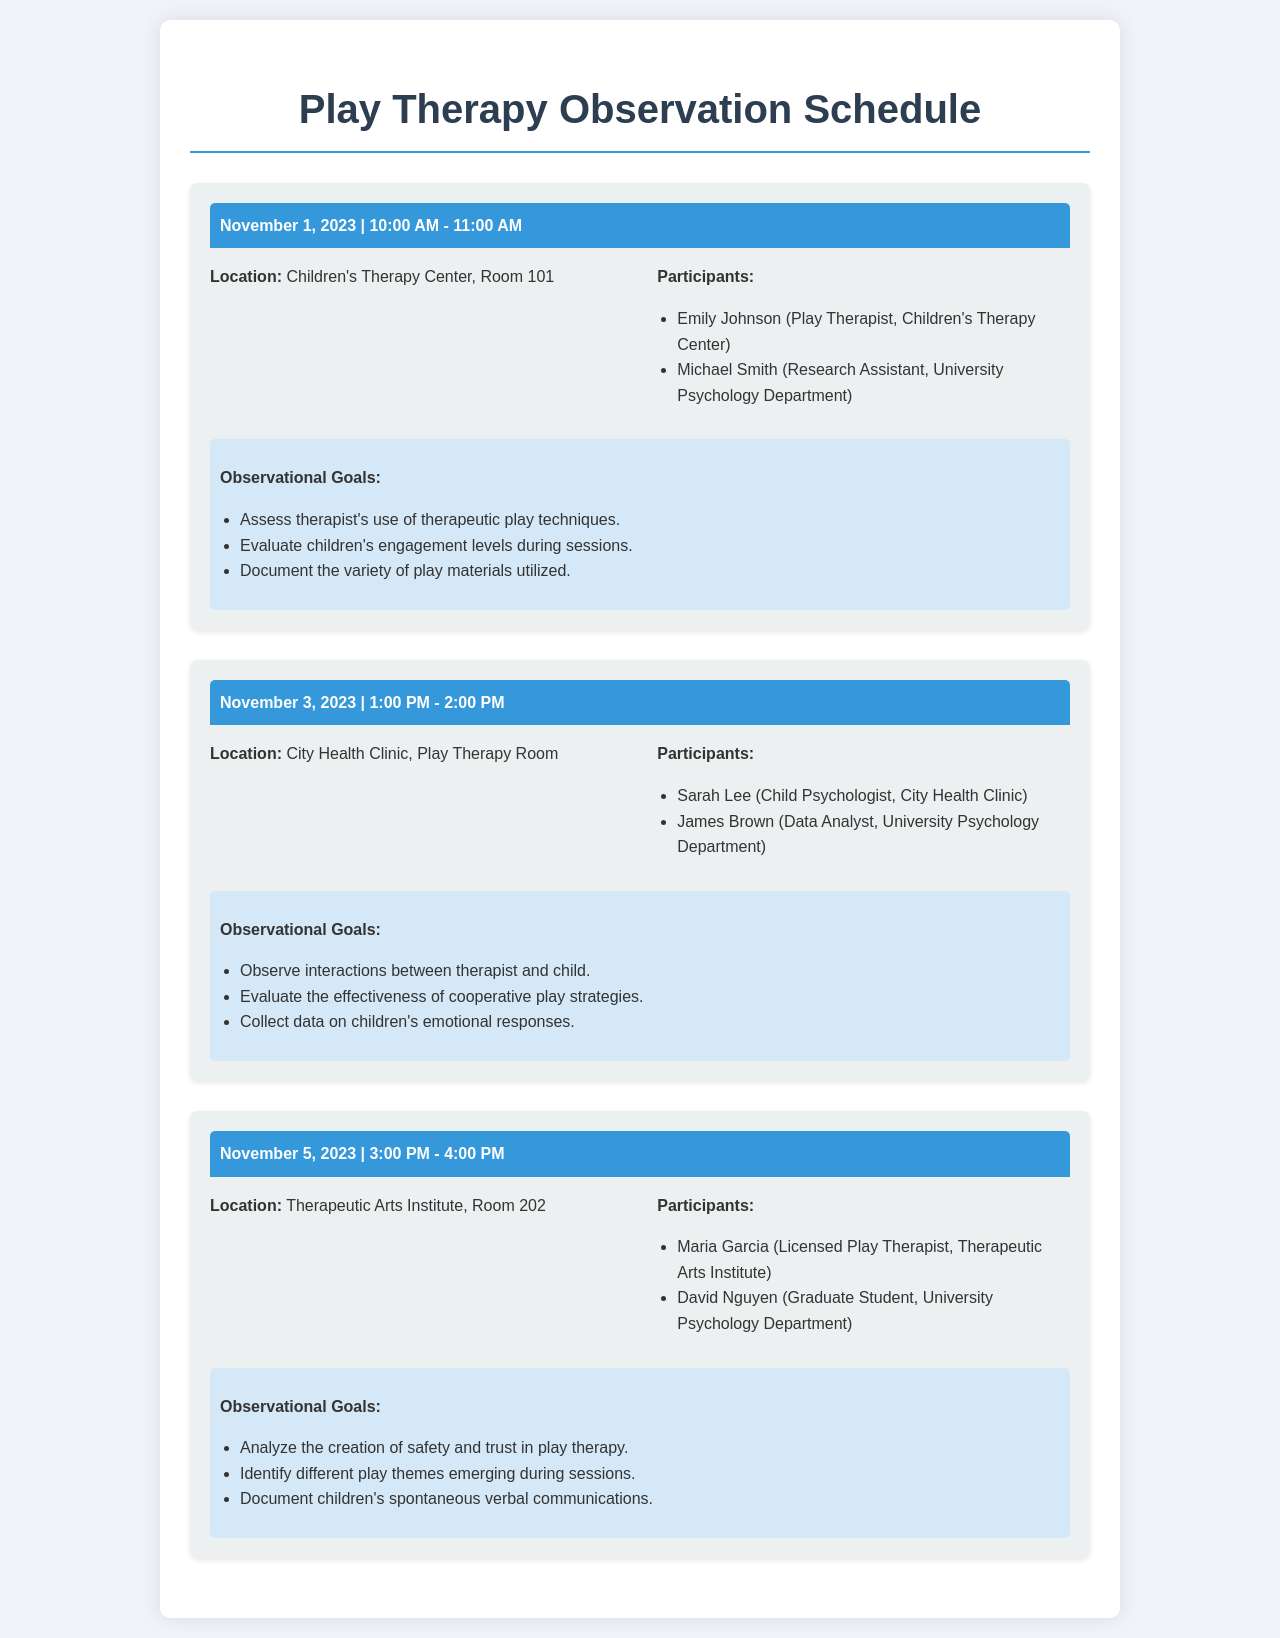What is the date of the first observation session? The first observation session is scheduled for November 1, 2023.
Answer: November 1, 2023 Who is the play therapist for the first session? Emily Johnson is listed as the play therapist for the first session.
Answer: Emily Johnson What is one of the observational goals for the second session? The second session's goals include observing interactions between therapist and child.
Answer: Observe interactions between therapist and child How many sessions are scheduled in total? There are three observation sessions outlined in the document.
Answer: Three What location is the second session held? The second session is held at City Health Clinic, Play Therapy Room.
Answer: City Health Clinic, Play Therapy Room Who is a participant in the last session? Maria Garcia is a participant in the last observation session.
Answer: Maria Garcia What time does the first session start? The first session begins at 10:00 AM.
Answer: 10:00 AM Which participant is a data analyst? James Brown is identified as the data analyst for the second session.
Answer: James Brown What is one goal for the last session? One goal for the last session is to analyze the creation of safety and trust in play therapy.
Answer: Analyze the creation of safety and trust in play therapy 